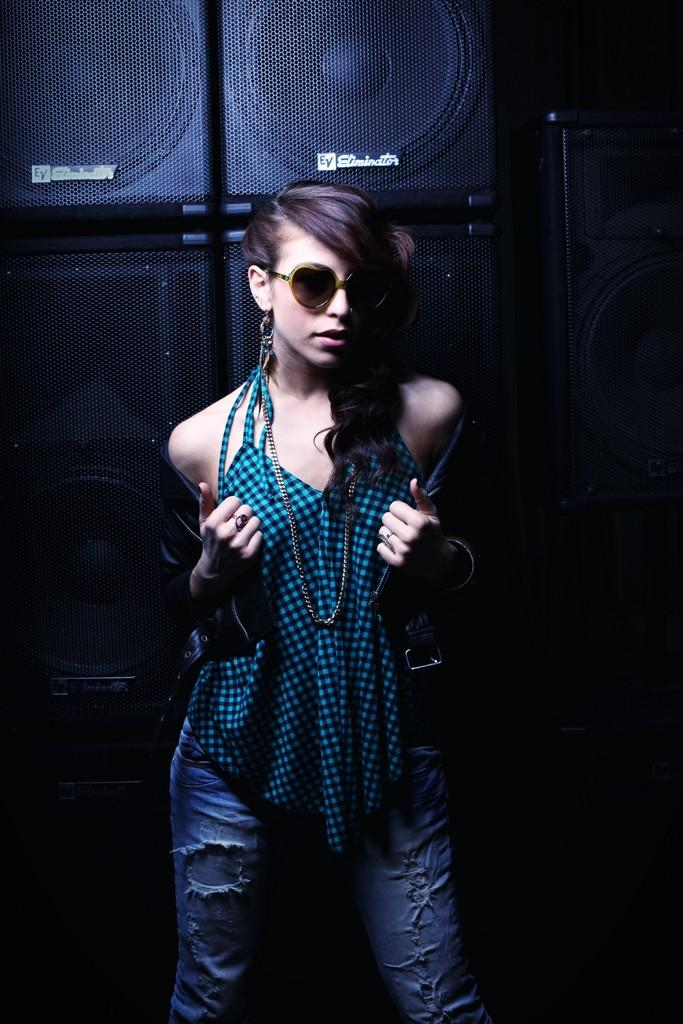Who is present in the image? There is a woman in the image. What accessories is the woman wearing? The woman is wearing a chain and goggles. What can be seen in the background of the image? There are speakers in the background of the image. What type of polish is the woman applying to the tiger in the image? There is no tiger or polish present in the image. How does the woman interact with the sea in the image? There is no sea present in the image. 